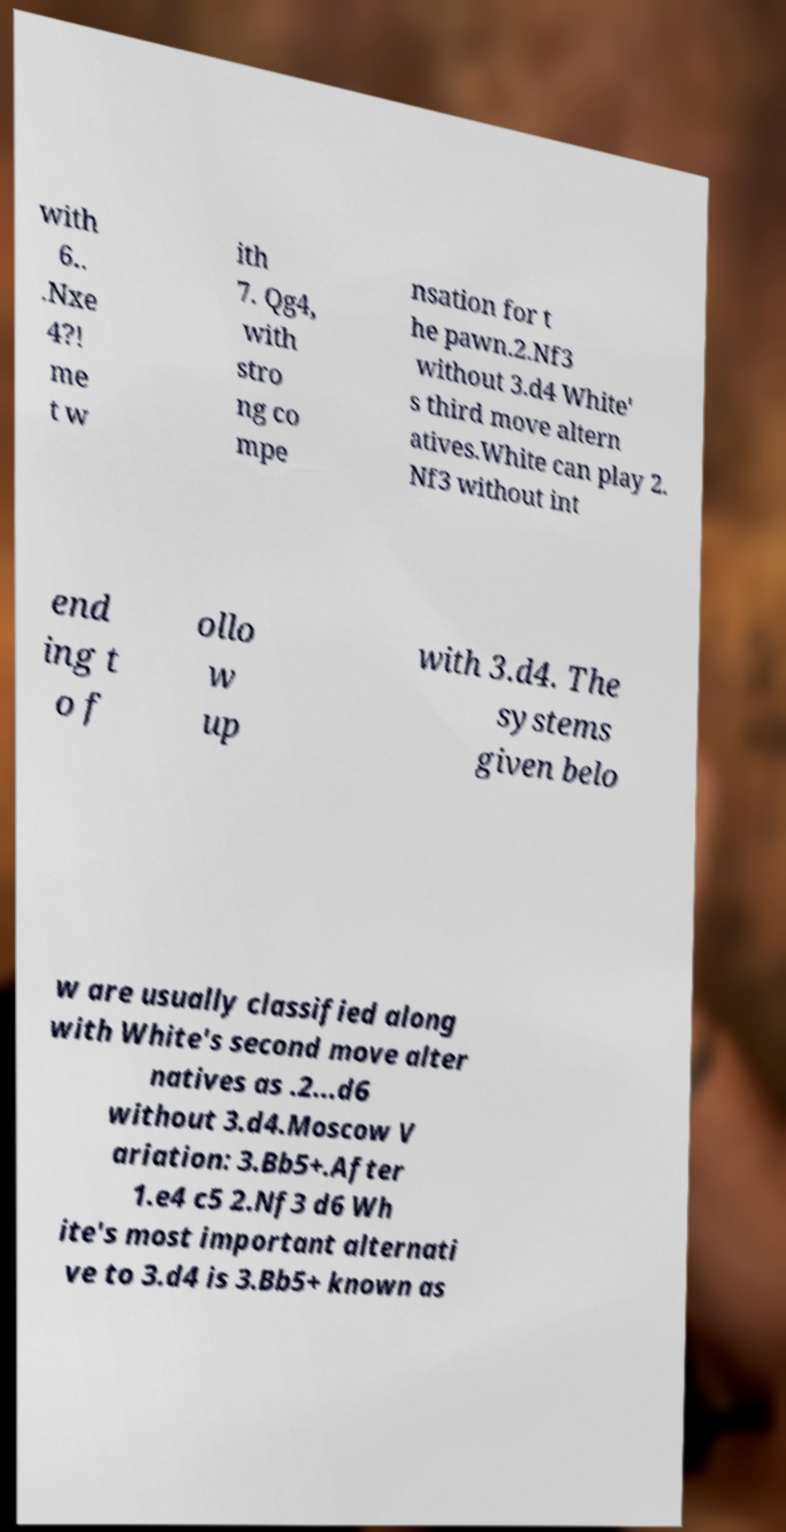There's text embedded in this image that I need extracted. Can you transcribe it verbatim? with 6.. .Nxe 4?! me t w ith 7. Qg4, with stro ng co mpe nsation for t he pawn.2.Nf3 without 3.d4 White' s third move altern atives.White can play 2. Nf3 without int end ing t o f ollo w up with 3.d4. The systems given belo w are usually classified along with White's second move alter natives as .2...d6 without 3.d4.Moscow V ariation: 3.Bb5+.After 1.e4 c5 2.Nf3 d6 Wh ite's most important alternati ve to 3.d4 is 3.Bb5+ known as 